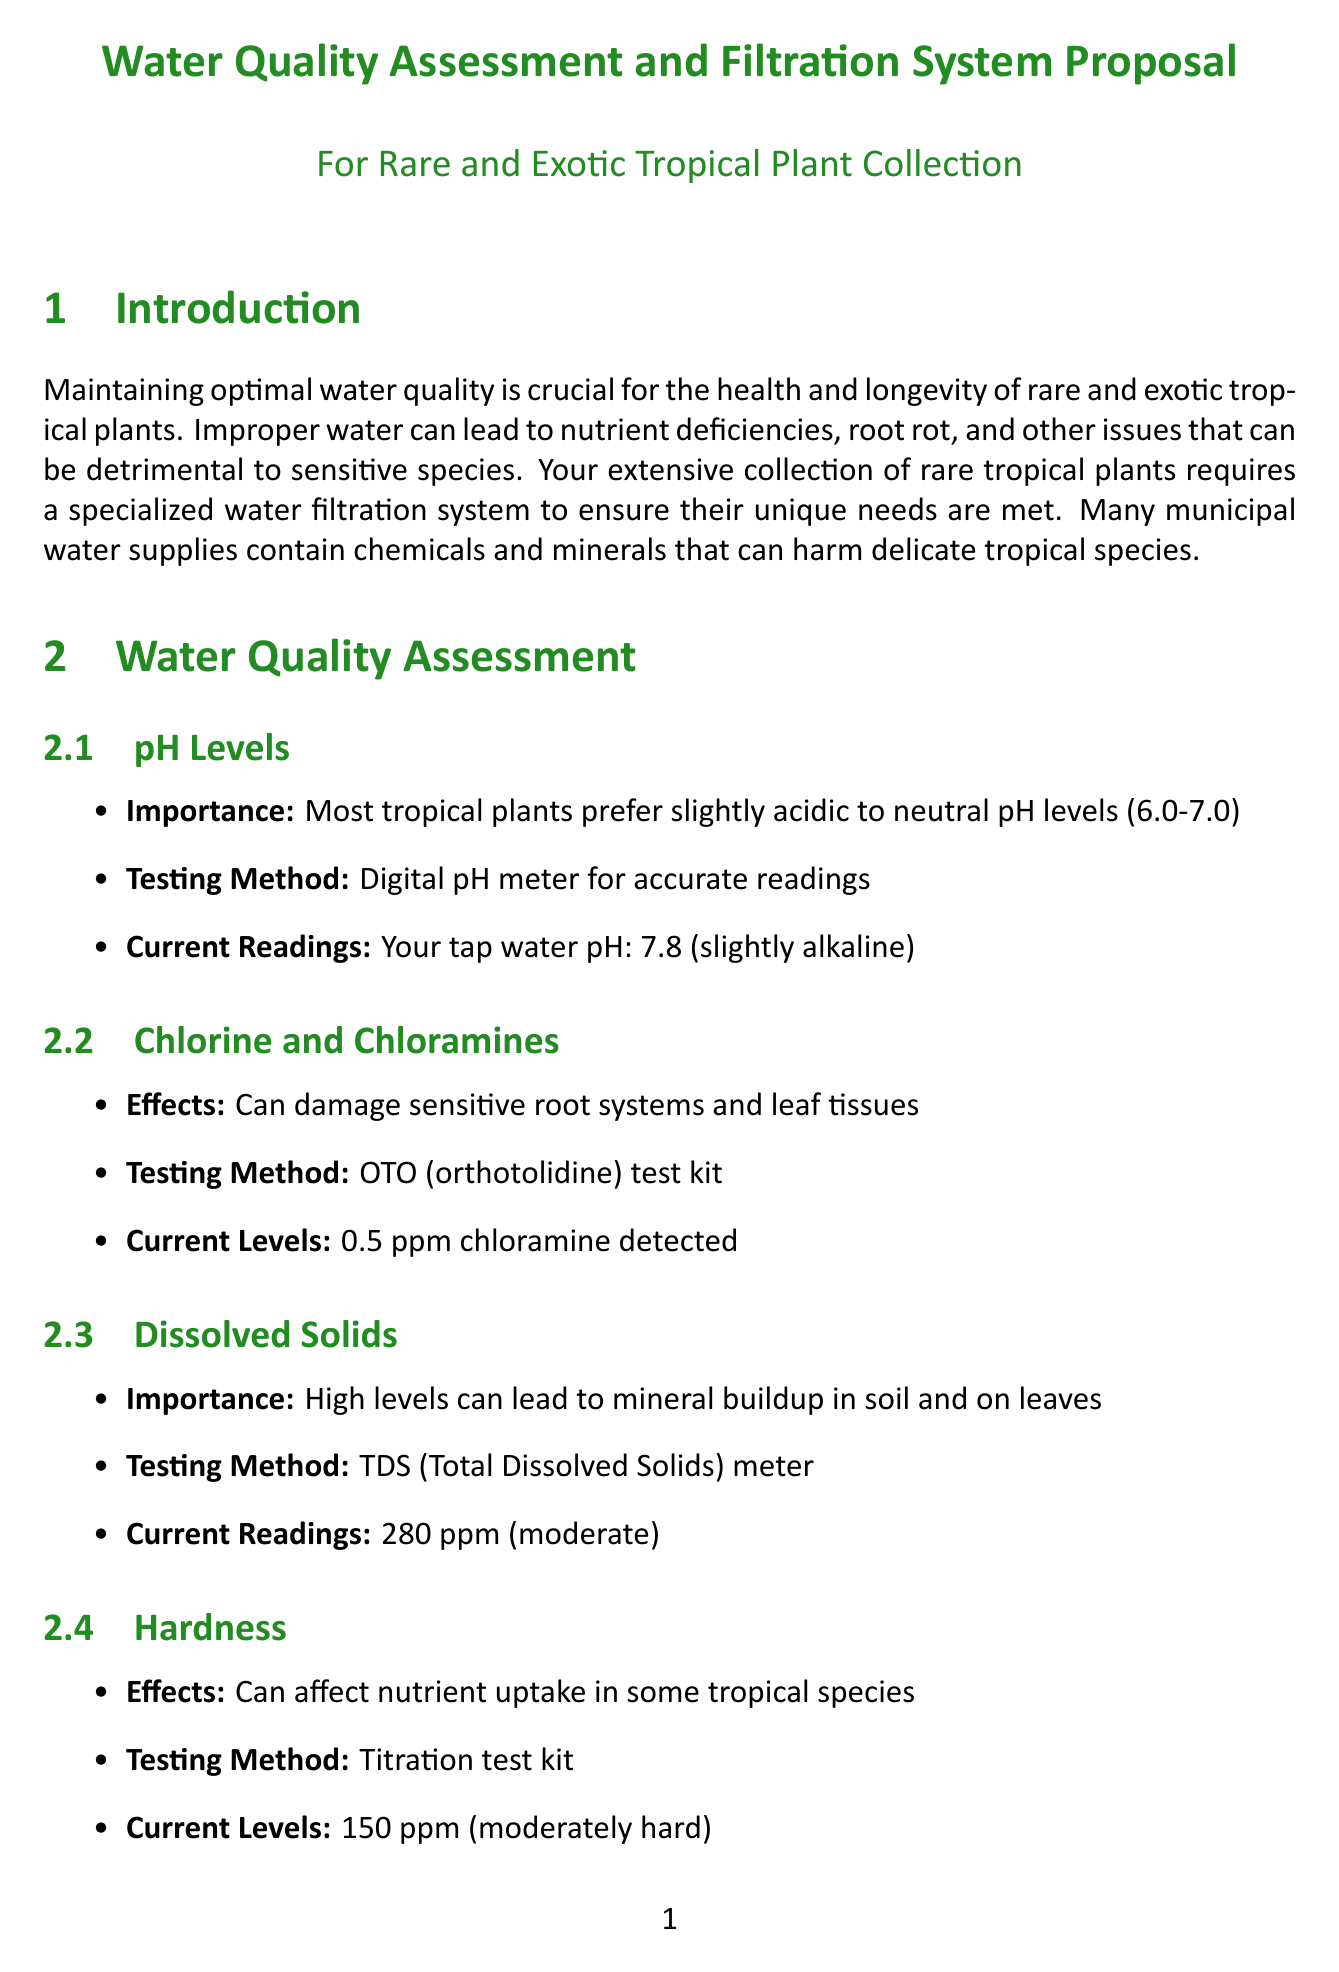What is the pH level of your tap water? The current reading of your tap water pH is stated in the document, which is 7.8.
Answer: 7.8 What is the recommended testing method for chlorine and chloramines? The document specifies using an OTO (orthotolidine) test kit for testing chlorine and chloramines.
Answer: OTO test kit What is the estimated cost for the installation of the filtration system? The document lists the estimated cost for installing the filtration system as between $1,200 and $1,500.
Answer: $1,200 - $1,500 Which plant requires pure, mineral-free water? The document identifies Nepenthes rajah as the plant requiring pure, mineral-free water.
Answer: Nepenthes rajah What are the benefits of the Reverse Osmosis system? The document states the benefits include removing up to 99% of contaminants, including chlorine, chloramines, and dissolved solids.
Answer: Removes up to 99% of contaminants How does the remineralization filter affect the pH levels? The document explains that the remineralization filter adds beneficial minerals back into purified water, adjusting the pH to ideal levels for tropical plants.
Answer: Adjusts pH to ideal levels What maintenance is required for the UV sterilizer? The maintenance requirement for the UV sterilizer is to change the UV lamp every 12 months as mentioned in the document.
Answer: UV lamp change every 12 months What long-term consideration is suggested for water conservation? The document suggests implementing a rainwater collection system to supplement the filtered water supply for long-term water conservation.
Answer: Rainwater collection system Which plant is sensitive to chlorine and fluoride? The document mentions that Anthurium veitchii is sensitive to chlorine and fluoride.
Answer: Anthurium veitchii 